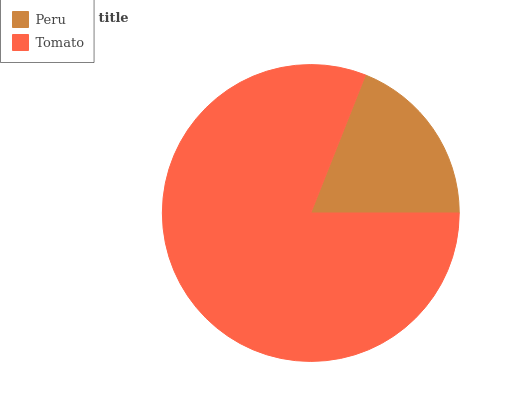Is Peru the minimum?
Answer yes or no. Yes. Is Tomato the maximum?
Answer yes or no. Yes. Is Tomato the minimum?
Answer yes or no. No. Is Tomato greater than Peru?
Answer yes or no. Yes. Is Peru less than Tomato?
Answer yes or no. Yes. Is Peru greater than Tomato?
Answer yes or no. No. Is Tomato less than Peru?
Answer yes or no. No. Is Tomato the high median?
Answer yes or no. Yes. Is Peru the low median?
Answer yes or no. Yes. Is Peru the high median?
Answer yes or no. No. Is Tomato the low median?
Answer yes or no. No. 